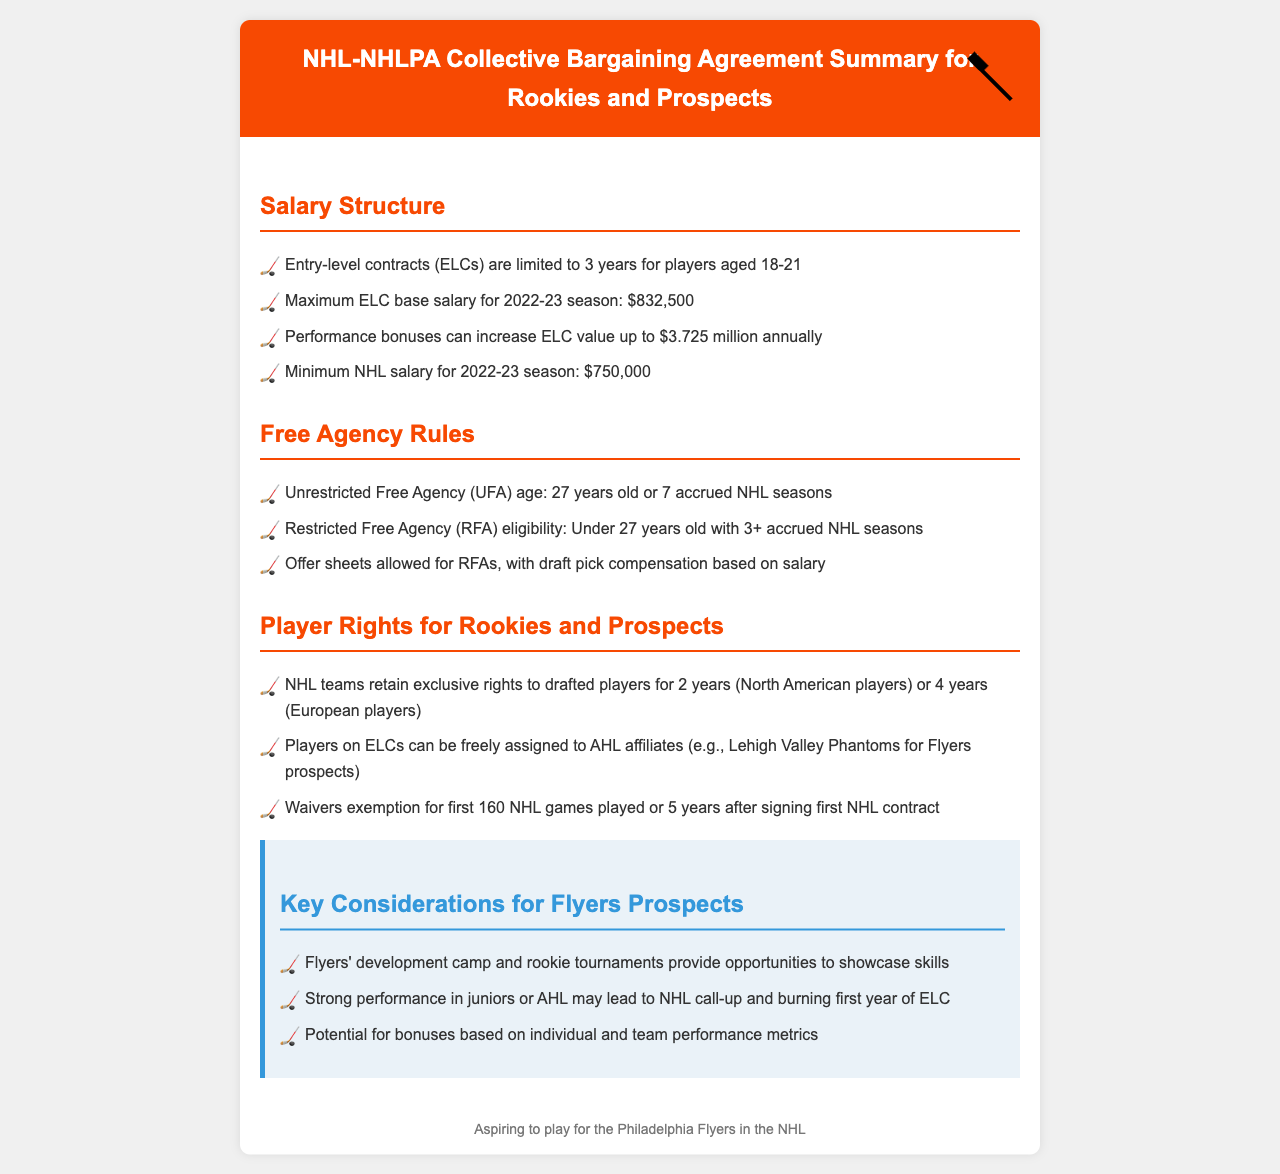what is the maximum ELC base salary for the 2022-23 season? The maximum entry-level contract base salary for the specified season is stated in the salary structure section.
Answer: $832,500 what is the age for unrestricted free agency? The age at which a player is eligible for unrestricted free agency is outlined in the free agency rules section.
Answer: 27 years old how long are entry-level contracts limited to for players aged 18-21? This information is given in the salary structure section and specifies the duration of entry-level contracts.
Answer: 3 years how many accrued NHL seasons are required for restricted free agency eligibility? The number of accrued NHL seasons needed for restricted free agency is mentioned in the free agency rules section.
Answer: 3+ what is the waivers exemption period after signing the first NHL contract? The document specifies the conditions for waivers exemption which includes time frames.
Answer: 5 years how many years of exclusive rights do NHL teams have to drafted European players? The section on player rights details the duration of exclusive rights for different player categories.
Answer: 4 years what is the minimum NHL salary for the 2022-23 season? The minimum salary for the NHL is provided in the salary structure section.
Answer: $750,000 what benefits can a strong performance in juniors lead to for Flyers prospects? The impact of strong performance is explained in the key considerations section, indicating potential career advancement opportunities.
Answer: NHL call-up how long can players on entry-level contracts be freely assigned to AHL affiliates? The document does not specify a time limit but indicates they can be assigned freely during their contract duration.
Answer: Until contract expires 